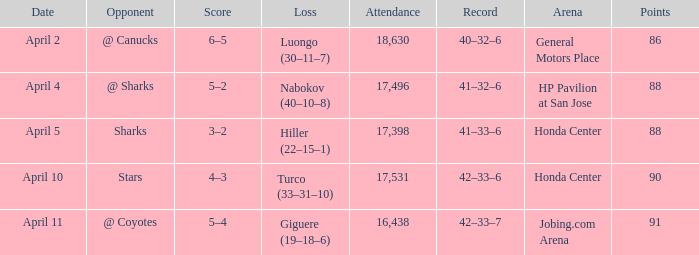On which date was the record 41–32–6? April 4. 